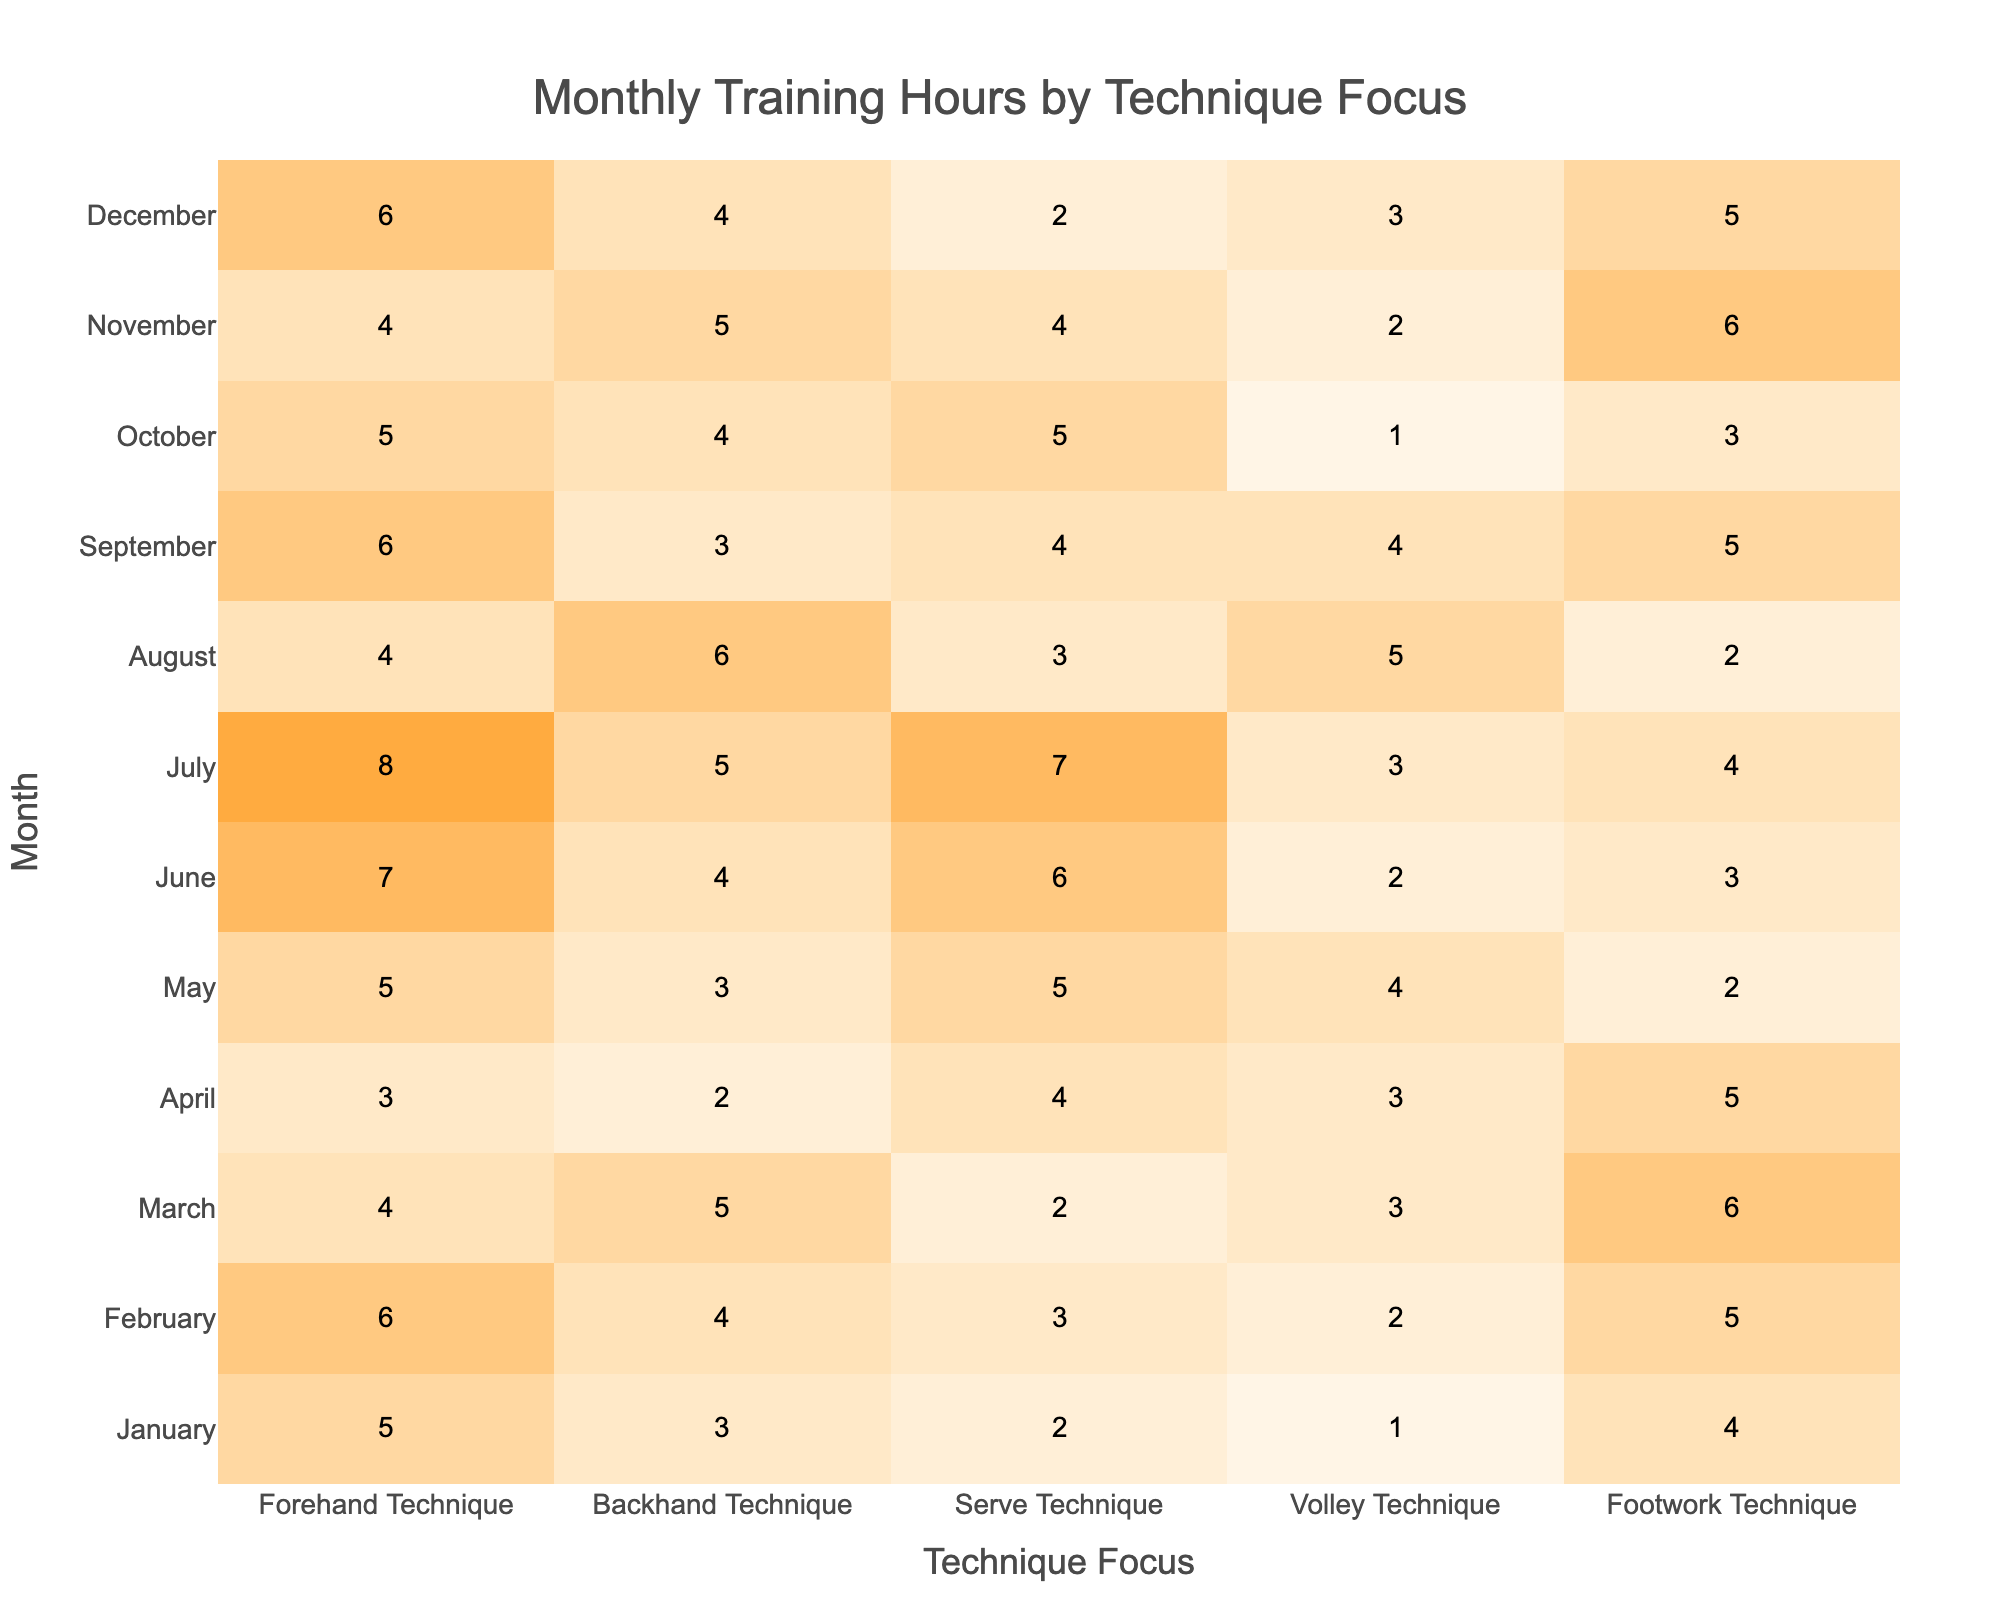What is the most training hour month for Forehand Technique? By examining the column for Forehand Technique, we find the maximum value is 8 hours in July.
Answer: July Which technique had the highest total training hours across all months? Adding up the training hours for each technique: Forehand (5+6+4+3+5+7+8+4+6+5+4+6 = 60), Backhand (3+4+5+2+3+4+5+6+3+4+5+4 = 54), Serve (2+3+2+4+5+6+7+3+4+5+4+2 = 57), Volley (1+2+3+3+4+2+3+5+4+1+2+3 = 36), and Footwork (4+5+6+5+2+3+4+2+5+3+6+5 = 57). The highest is Forehand with 60 hours.
Answer: Forehand Technique What month had the least focus on Volley Technique? Looking at the Volley Technique column, the lowest value is 1 hour in January.
Answer: January What is the average training hour for Backhand Technique? The total hours for Backhand are: 3+4+5+2+3+4+5+6+3+4+5+4 = 54 hours. There are 12 months, so the average is 54/12 = 4.5.
Answer: 4.5 Did any month see equal training hours for both Forehand and Backhand Techniques? Checking the Forehand and Backhand columns, we see no month where the values are equal. Therefore, the answer is no.
Answer: No What was the difference in training hours between the month with the highest and lowest serve technique focus? The highest serve technique hours were 7 in July, while the lowest was 2 in January. The difference is 7 - 2 = 5 hours.
Answer: 5 Which technique had the highest training hours in March? In March, the training hours were: Forehand (4), Backhand (5), Serve (2), Volley (3), Footwork (6). The maximum is for Footwork with 6 hours.
Answer: Footwork Technique How many total training hours were dedicated to Footwork Technique from April to June? Summing Footwork hours in April (5), May (2), and June (3) gives us 5 + 2 + 3 = 10 total hours.
Answer: 10 In which month did the Serve Technique see a decrease in training hours compared to the previous month? Comparing the Serve Technique hours: January (2), February (3), March (2), April (4), May (5), June (6), July (7), August (3), September (4), October (5), November (4), December (2). We see a decrease in August from 7 to 3.
Answer: August Which technique experienced the highest variability in training hours across the year? To find variability, we can observe the range for each technique. For example, Forehand extends from 3 to 8 (range of 5), Backhand from 2 to 6 (range of 4), Serve from 2 to 7 (range of 5), Volley from 1 to 5 (range of 4), and Footwork from 2 to 6 (range of 4). The highest variability is in Forehand and Serve, both with a range of 5.
Answer: Forehand and Serve Techniques 